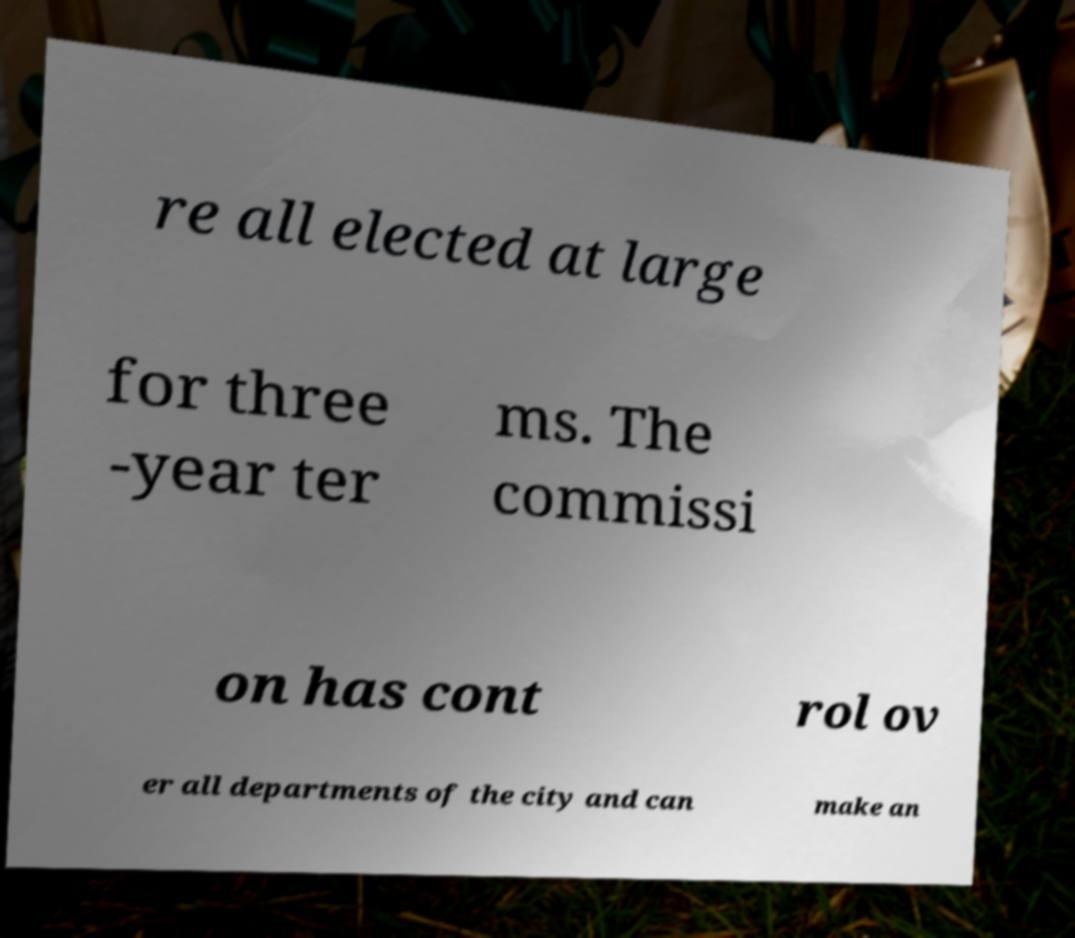Please read and relay the text visible in this image. What does it say? re all elected at large for three -year ter ms. The commissi on has cont rol ov er all departments of the city and can make an 